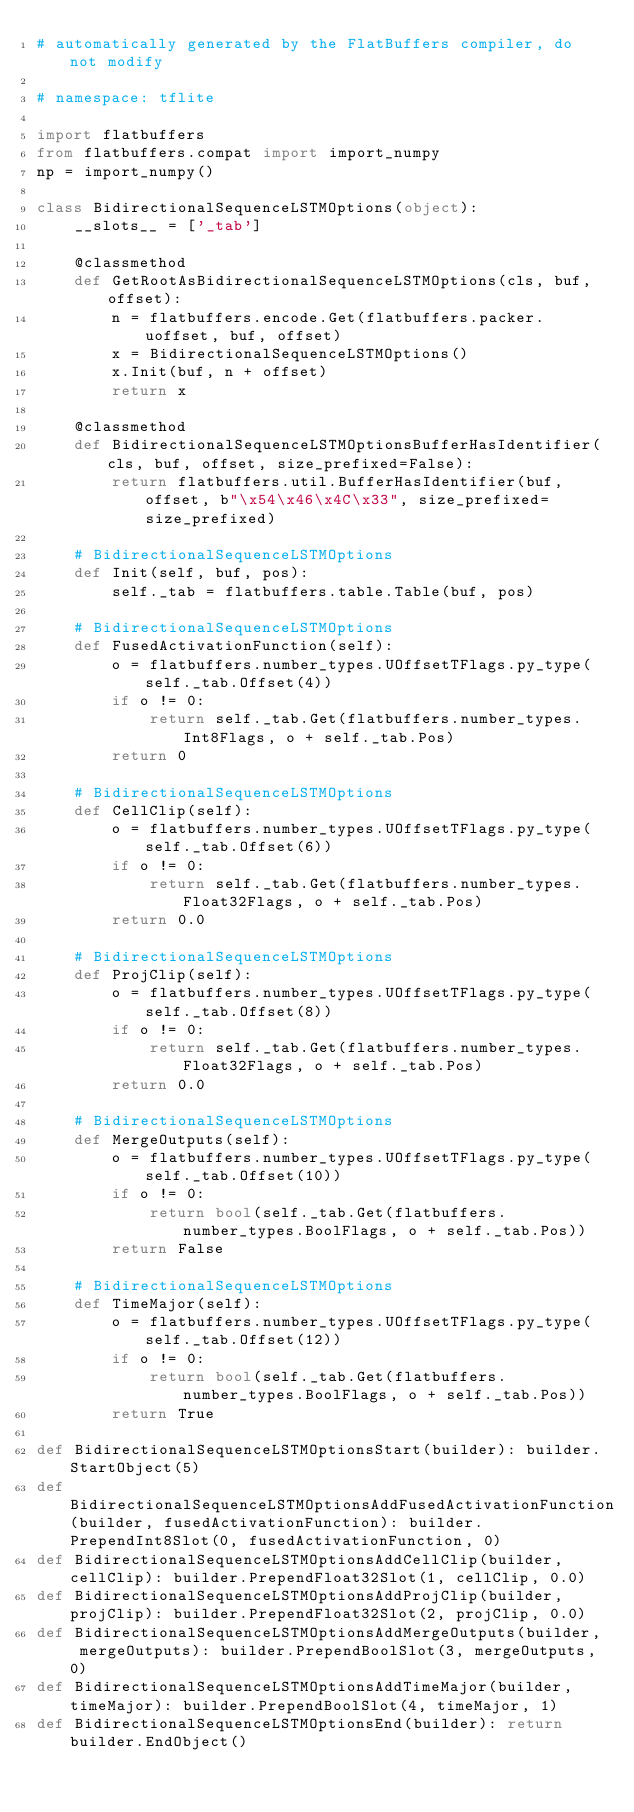<code> <loc_0><loc_0><loc_500><loc_500><_Python_># automatically generated by the FlatBuffers compiler, do not modify

# namespace: tflite

import flatbuffers
from flatbuffers.compat import import_numpy
np = import_numpy()

class BidirectionalSequenceLSTMOptions(object):
    __slots__ = ['_tab']

    @classmethod
    def GetRootAsBidirectionalSequenceLSTMOptions(cls, buf, offset):
        n = flatbuffers.encode.Get(flatbuffers.packer.uoffset, buf, offset)
        x = BidirectionalSequenceLSTMOptions()
        x.Init(buf, n + offset)
        return x

    @classmethod
    def BidirectionalSequenceLSTMOptionsBufferHasIdentifier(cls, buf, offset, size_prefixed=False):
        return flatbuffers.util.BufferHasIdentifier(buf, offset, b"\x54\x46\x4C\x33", size_prefixed=size_prefixed)

    # BidirectionalSequenceLSTMOptions
    def Init(self, buf, pos):
        self._tab = flatbuffers.table.Table(buf, pos)

    # BidirectionalSequenceLSTMOptions
    def FusedActivationFunction(self):
        o = flatbuffers.number_types.UOffsetTFlags.py_type(self._tab.Offset(4))
        if o != 0:
            return self._tab.Get(flatbuffers.number_types.Int8Flags, o + self._tab.Pos)
        return 0

    # BidirectionalSequenceLSTMOptions
    def CellClip(self):
        o = flatbuffers.number_types.UOffsetTFlags.py_type(self._tab.Offset(6))
        if o != 0:
            return self._tab.Get(flatbuffers.number_types.Float32Flags, o + self._tab.Pos)
        return 0.0

    # BidirectionalSequenceLSTMOptions
    def ProjClip(self):
        o = flatbuffers.number_types.UOffsetTFlags.py_type(self._tab.Offset(8))
        if o != 0:
            return self._tab.Get(flatbuffers.number_types.Float32Flags, o + self._tab.Pos)
        return 0.0

    # BidirectionalSequenceLSTMOptions
    def MergeOutputs(self):
        o = flatbuffers.number_types.UOffsetTFlags.py_type(self._tab.Offset(10))
        if o != 0:
            return bool(self._tab.Get(flatbuffers.number_types.BoolFlags, o + self._tab.Pos))
        return False

    # BidirectionalSequenceLSTMOptions
    def TimeMajor(self):
        o = flatbuffers.number_types.UOffsetTFlags.py_type(self._tab.Offset(12))
        if o != 0:
            return bool(self._tab.Get(flatbuffers.number_types.BoolFlags, o + self._tab.Pos))
        return True

def BidirectionalSequenceLSTMOptionsStart(builder): builder.StartObject(5)
def BidirectionalSequenceLSTMOptionsAddFusedActivationFunction(builder, fusedActivationFunction): builder.PrependInt8Slot(0, fusedActivationFunction, 0)
def BidirectionalSequenceLSTMOptionsAddCellClip(builder, cellClip): builder.PrependFloat32Slot(1, cellClip, 0.0)
def BidirectionalSequenceLSTMOptionsAddProjClip(builder, projClip): builder.PrependFloat32Slot(2, projClip, 0.0)
def BidirectionalSequenceLSTMOptionsAddMergeOutputs(builder, mergeOutputs): builder.PrependBoolSlot(3, mergeOutputs, 0)
def BidirectionalSequenceLSTMOptionsAddTimeMajor(builder, timeMajor): builder.PrependBoolSlot(4, timeMajor, 1)
def BidirectionalSequenceLSTMOptionsEnd(builder): return builder.EndObject()
</code> 